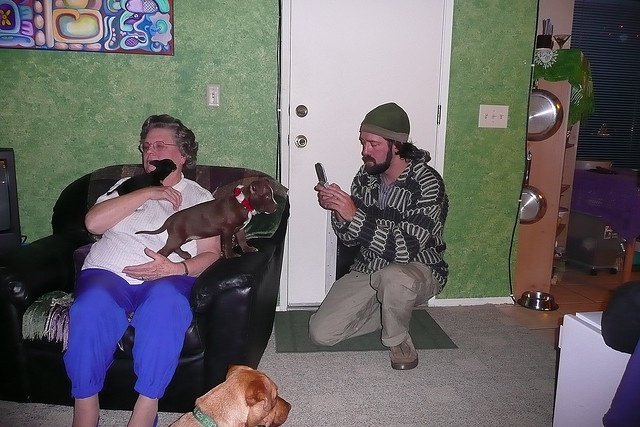Describe the objects in this image and their specific colors. I can see chair in blue, black, gray, and navy tones, couch in blue, black, gray, and navy tones, people in blue, darkblue, gray, and darkgray tones, people in blue, gray, black, and darkgray tones, and dog in blue, maroon, black, brown, and darkgray tones in this image. 